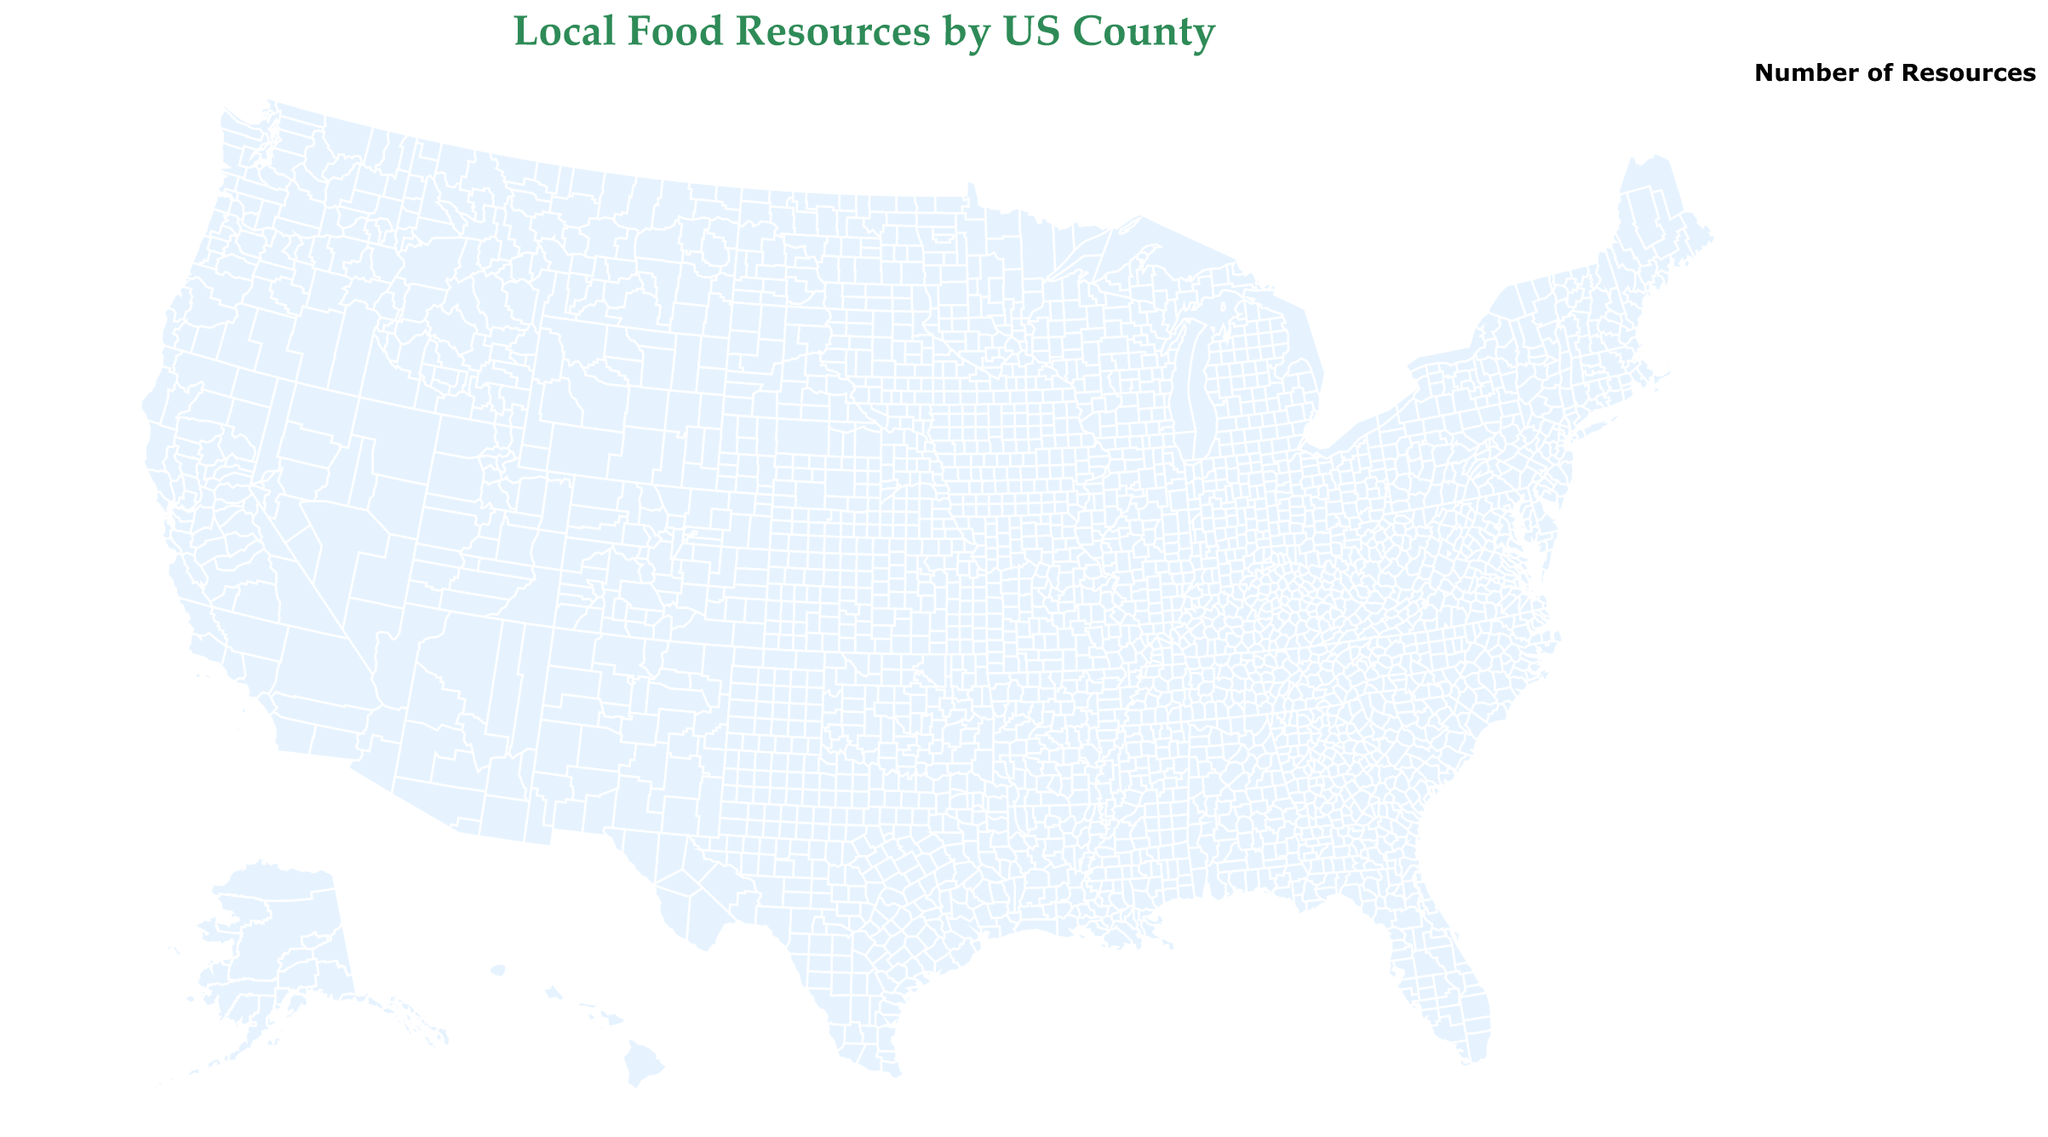What is the title of the figure? The title of the figure is displayed at the top and usually indicates the main topic or focus. It reads "Local Food Resources by US County."
Answer: Local Food Resources by US County Which county in Washington has the highest number of farmers markets? On the map, we can see two counties in Washington: King and Thurston. By examining the data points, we see that King County has 40 farmers markets, while Thurston has 14. Therefore, King has the highest number.
Answer: King How many food co-ops are there in Boulder County, Colorado? To find the number of food co-ops in Boulder, Colorado, refer to the data point labeled Boulder and note its corresponding value for Food Coops, which is 5.
Answer: 5 Which county has the highest number of local herb vendors? To find the county with the highest number of local herb vendors, look for the data point with the largest circle and highest value for Local Herb Vendors. Sonoma County, California, has the highest with 22 vendors.
Answer: Sonoma What is the average number of farmers markets across all listed counties? To find the average, sum the number of farmers markets across all counties and divide by the number of counties: (40+28+15+35+12+18+8+11+6+22+9+14+17+10+25) / 15. The total is 270, and the average is 270 / 15.
Answer: 18 Which county has more farmers markets: Travis, Texas, or Dane, Wisconsin? Compare the number of farmers markets for Travis (15) and Dane (18) by looking at their data points in the map. Dane has more farmers markets than Travis.
Answer: Dane What is the combined total of farmers markets and food co-ops in Lane County, Oregon? Sum the number of farmers markets (25) and food co-ops (6) in Lane County: 25 + 6.
Answer: 31 Is Chittenden County, Vermont, more abundant in farmers markets or local herb vendors? Compare the number of farmers markets (10) with the number of local herb vendors (9) for Chittenden. Farmers markets are more abundant.
Answer: Farmers markets Which has more local herb vendors, Sonoma County, California, or Multnomah County, Oregon? Evaluate the number of local herb vendors for Sonoma (22) and Multnomah (18). Sonoma has more local herb vendors.
Answer: Sonoma What is the median number of food co-ops across the counties? Arrange the food co-ops counts in ascending order: 2, 3, 3, 3, 4, 4, 4, 4, 5, 5, 5, 6, 6, 7, 8, 9. The median is the middle value in the ordered list. With 15 values, the median is the 8th value, which is 4.
Answer: 4 